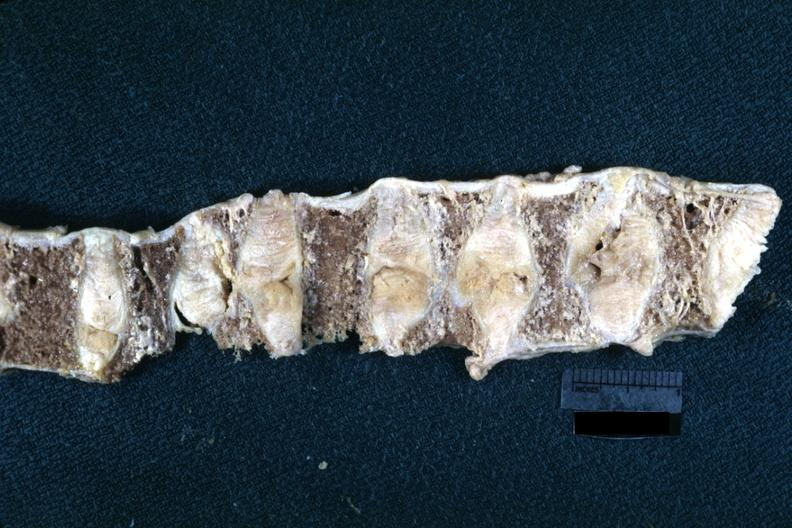what is fixed tissue lateral view of vertebral bodies with many collapsed?
Answer the question using a single word or phrase. Case rheumatoid arthritis 